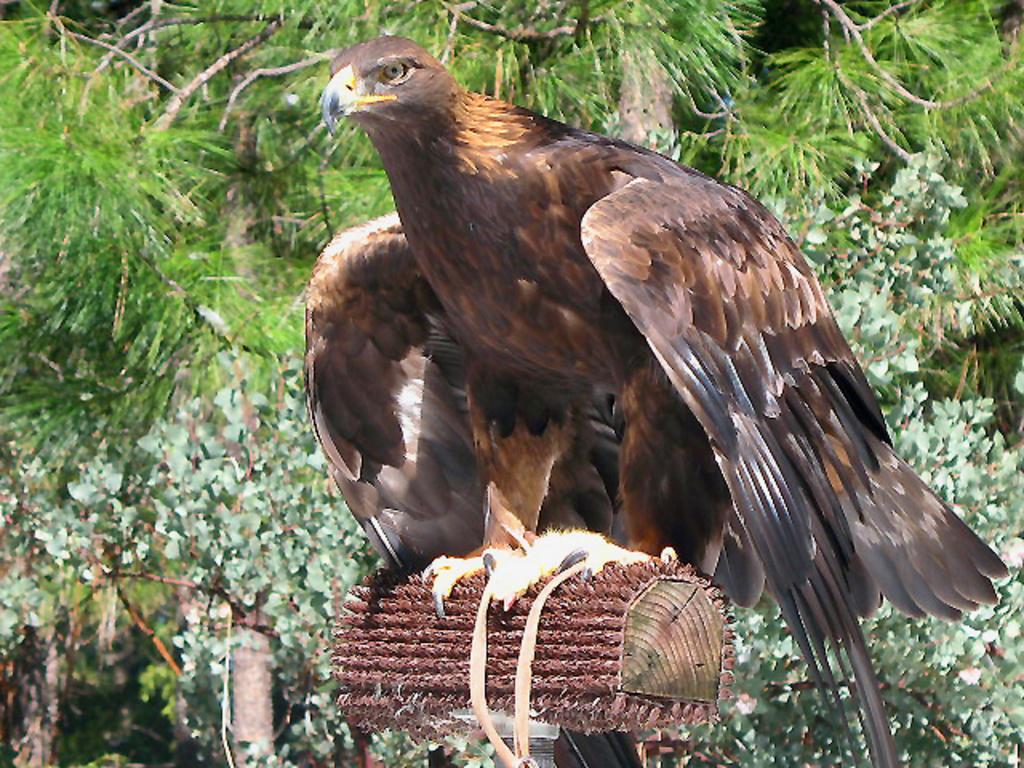Describe this image in one or two sentences. In this image I can see a bird, trees and wooden object. 